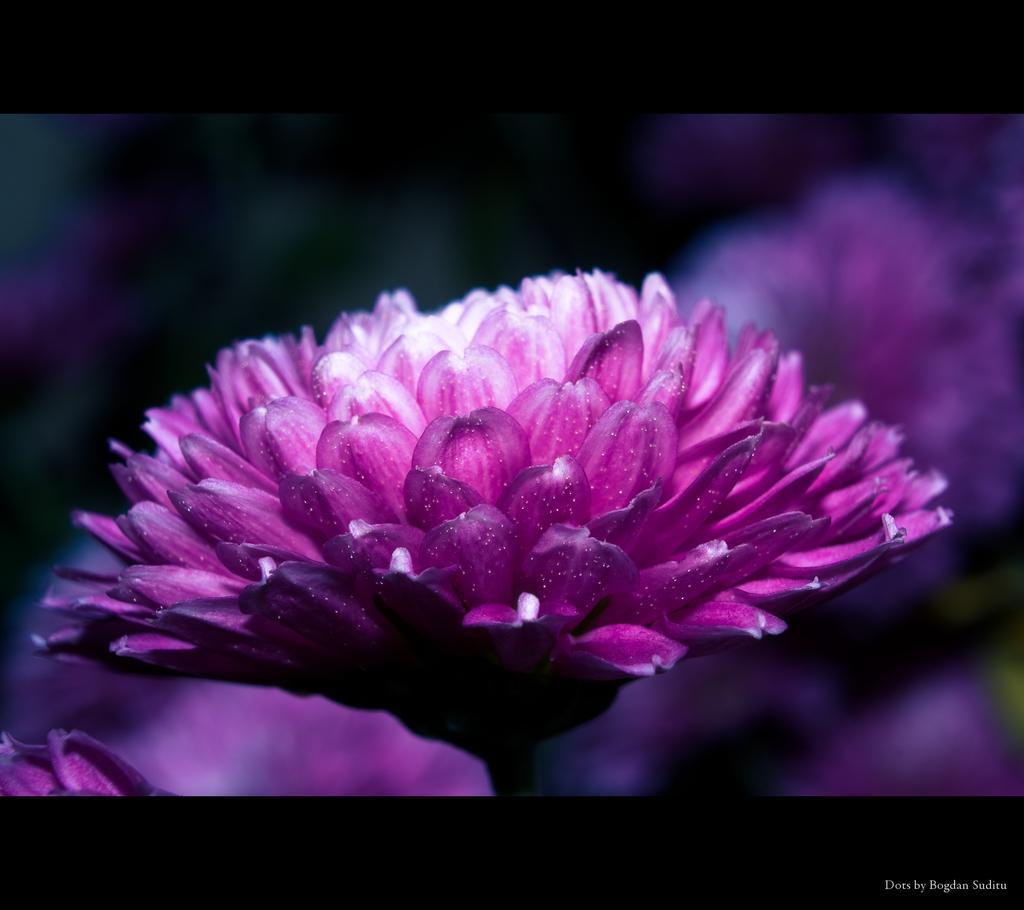Please provide a concise description of this image. In this image we can see flower. Background it is blur. Bottom of the image there is a watermark. 